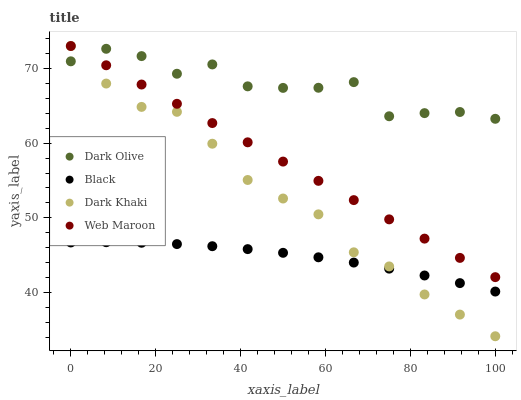Does Black have the minimum area under the curve?
Answer yes or no. Yes. Does Dark Olive have the maximum area under the curve?
Answer yes or no. Yes. Does Web Maroon have the minimum area under the curve?
Answer yes or no. No. Does Web Maroon have the maximum area under the curve?
Answer yes or no. No. Is Web Maroon the smoothest?
Answer yes or no. Yes. Is Dark Olive the roughest?
Answer yes or no. Yes. Is Dark Olive the smoothest?
Answer yes or no. No. Is Web Maroon the roughest?
Answer yes or no. No. Does Dark Khaki have the lowest value?
Answer yes or no. Yes. Does Web Maroon have the lowest value?
Answer yes or no. No. Does Web Maroon have the highest value?
Answer yes or no. Yes. Does Dark Olive have the highest value?
Answer yes or no. No. Is Black less than Dark Olive?
Answer yes or no. Yes. Is Dark Olive greater than Black?
Answer yes or no. Yes. Does Black intersect Dark Khaki?
Answer yes or no. Yes. Is Black less than Dark Khaki?
Answer yes or no. No. Is Black greater than Dark Khaki?
Answer yes or no. No. Does Black intersect Dark Olive?
Answer yes or no. No. 